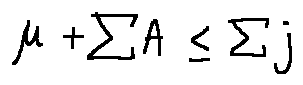<formula> <loc_0><loc_0><loc_500><loc_500>\mu + \sum A \leq \sum j</formula> 